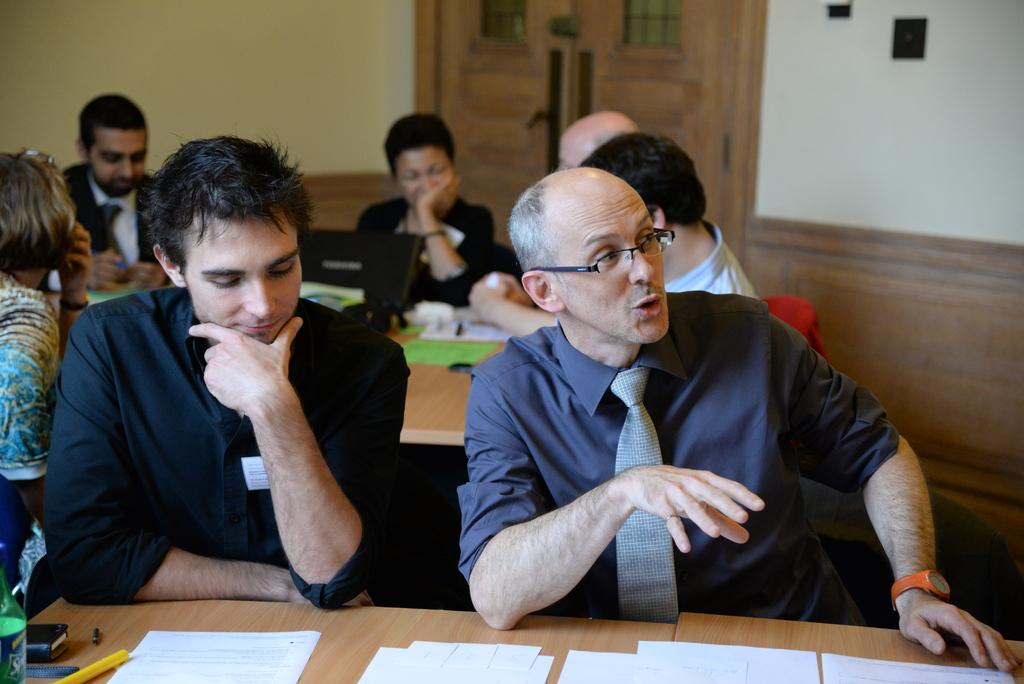How many people are sitting at the table with the two men? There is a group of people sitting at another table. Can you describe the seating arrangement in the image? There are two men sitting at one table, and a group of people are sitting at another table. What type of badge is the boat wearing in the image? There is no boat or badge present in the image. How many slaves are visible in the image? There is no mention of slaves in the image, and therefore no such individuals can be observed. 